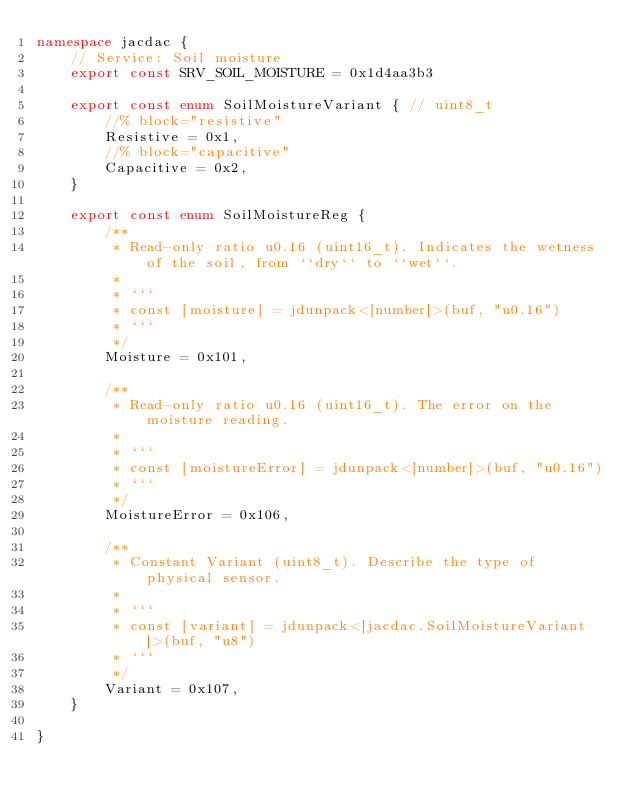Convert code to text. <code><loc_0><loc_0><loc_500><loc_500><_TypeScript_>namespace jacdac {
    // Service: Soil moisture
    export const SRV_SOIL_MOISTURE = 0x1d4aa3b3

    export const enum SoilMoistureVariant { // uint8_t
        //% block="resistive"
        Resistive = 0x1,
        //% block="capacitive"
        Capacitive = 0x2,
    }

    export const enum SoilMoistureReg {
        /**
         * Read-only ratio u0.16 (uint16_t). Indicates the wetness of the soil, from ``dry`` to ``wet``.
         *
         * ```
         * const [moisture] = jdunpack<[number]>(buf, "u0.16")
         * ```
         */
        Moisture = 0x101,

        /**
         * Read-only ratio u0.16 (uint16_t). The error on the moisture reading.
         *
         * ```
         * const [moistureError] = jdunpack<[number]>(buf, "u0.16")
         * ```
         */
        MoistureError = 0x106,

        /**
         * Constant Variant (uint8_t). Describe the type of physical sensor.
         *
         * ```
         * const [variant] = jdunpack<[jacdac.SoilMoistureVariant]>(buf, "u8")
         * ```
         */
        Variant = 0x107,
    }

}
</code> 